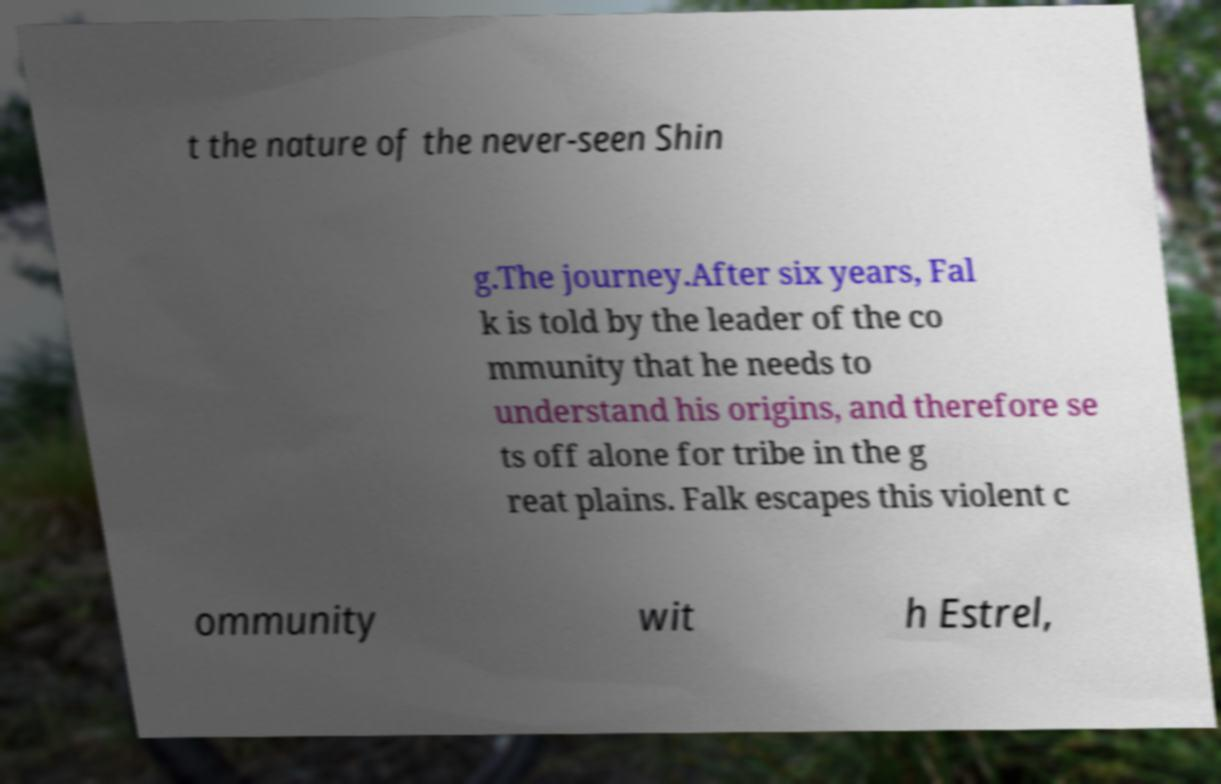Could you extract and type out the text from this image? t the nature of the never-seen Shin g.The journey.After six years, Fal k is told by the leader of the co mmunity that he needs to understand his origins, and therefore se ts off alone for tribe in the g reat plains. Falk escapes this violent c ommunity wit h Estrel, 